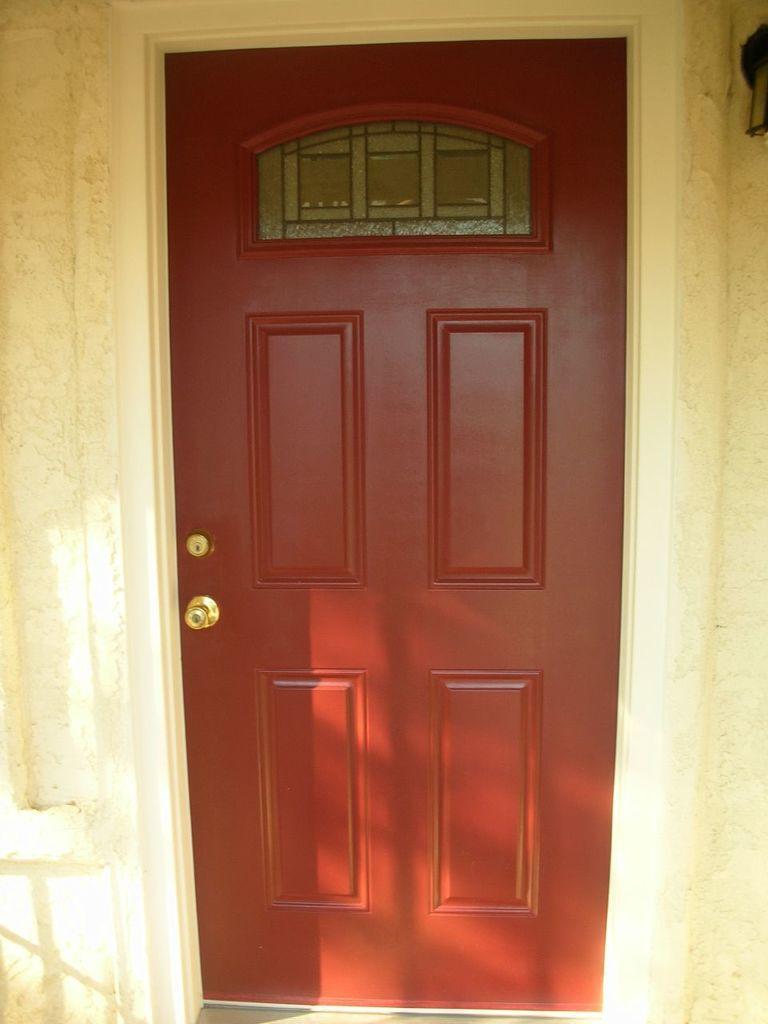In one or two sentences, can you explain what this image depicts? In this picture ,this is looking like the front door. 